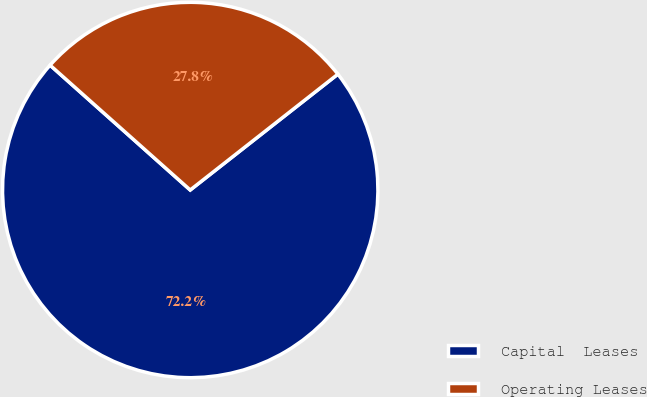Convert chart. <chart><loc_0><loc_0><loc_500><loc_500><pie_chart><fcel>Capital  Leases<fcel>Operating Leases<nl><fcel>72.17%<fcel>27.83%<nl></chart> 